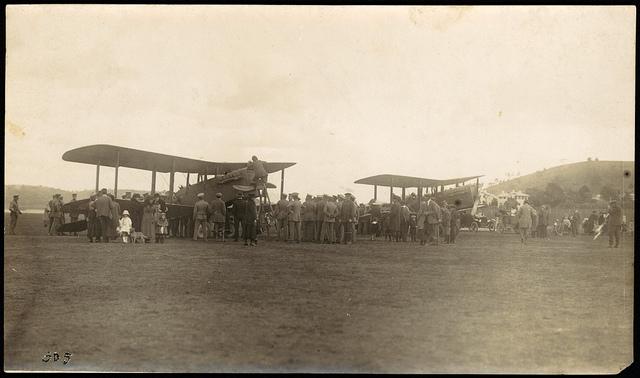Are these jet airplanes?
Keep it brief. No. Is there a very old plane in this picture?
Quick response, please. Yes. Do the people appear bored by the plane?
Keep it brief. No. 